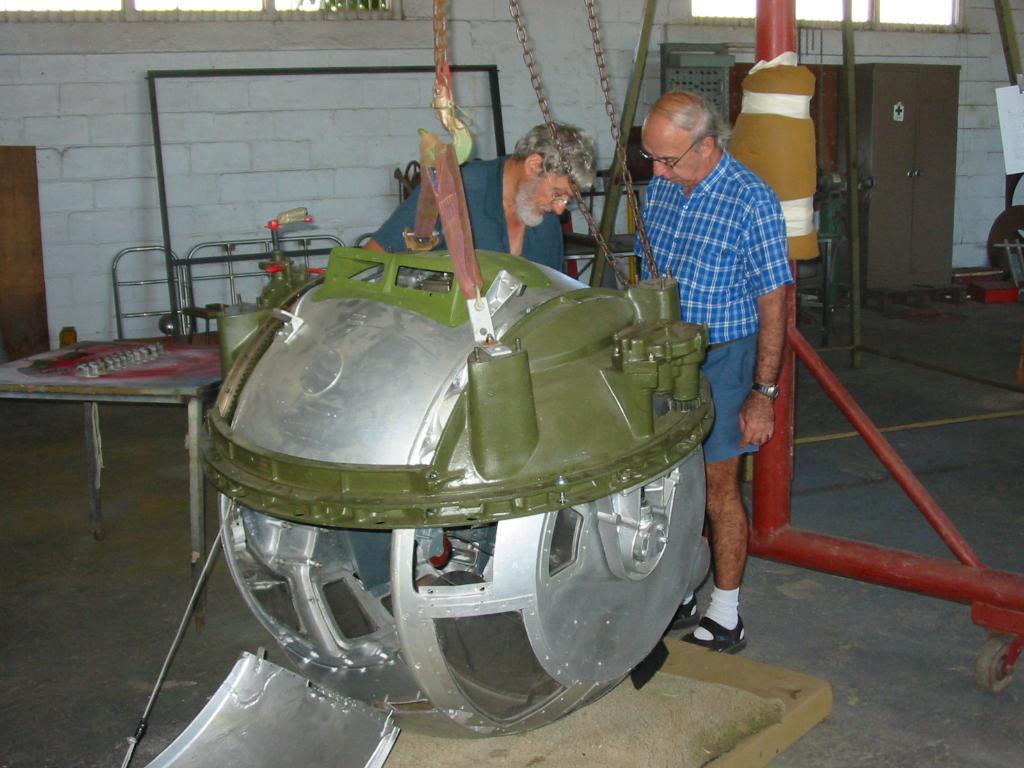How would you summarize this image in a sentence or two? In this image in the front there is an object which is green and silver in colour and in the center there are persons standing. In the background there is an almirah and there are rods, there is a wall and there are windows. 